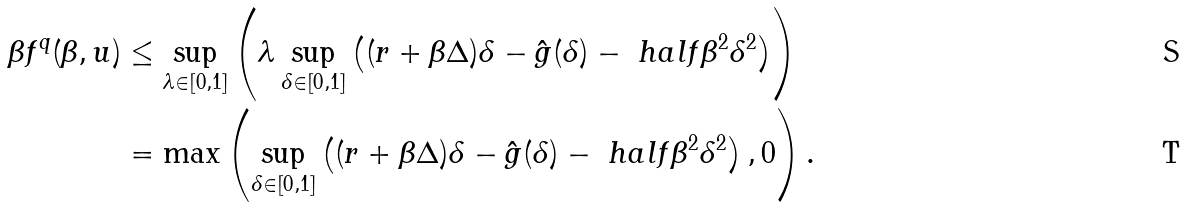Convert formula to latex. <formula><loc_0><loc_0><loc_500><loc_500>\beta f ^ { q } ( \beta , u ) & \leq \sup _ { \lambda \in [ 0 , 1 ] } \left ( \lambda \sup _ { \delta \in [ 0 , 1 ] } \left ( ( r + \beta \Delta ) \delta - \hat { g } ( \delta ) - \ h a l f \beta ^ { 2 } \delta ^ { 2 } \right ) \right ) \\ & = \max \left ( \sup _ { \delta \in [ 0 , 1 ] } \left ( ( r + \beta \Delta ) \delta - \hat { g } ( \delta ) - \ h a l f \beta ^ { 2 } \delta ^ { 2 } \right ) , 0 \right ) .</formula> 